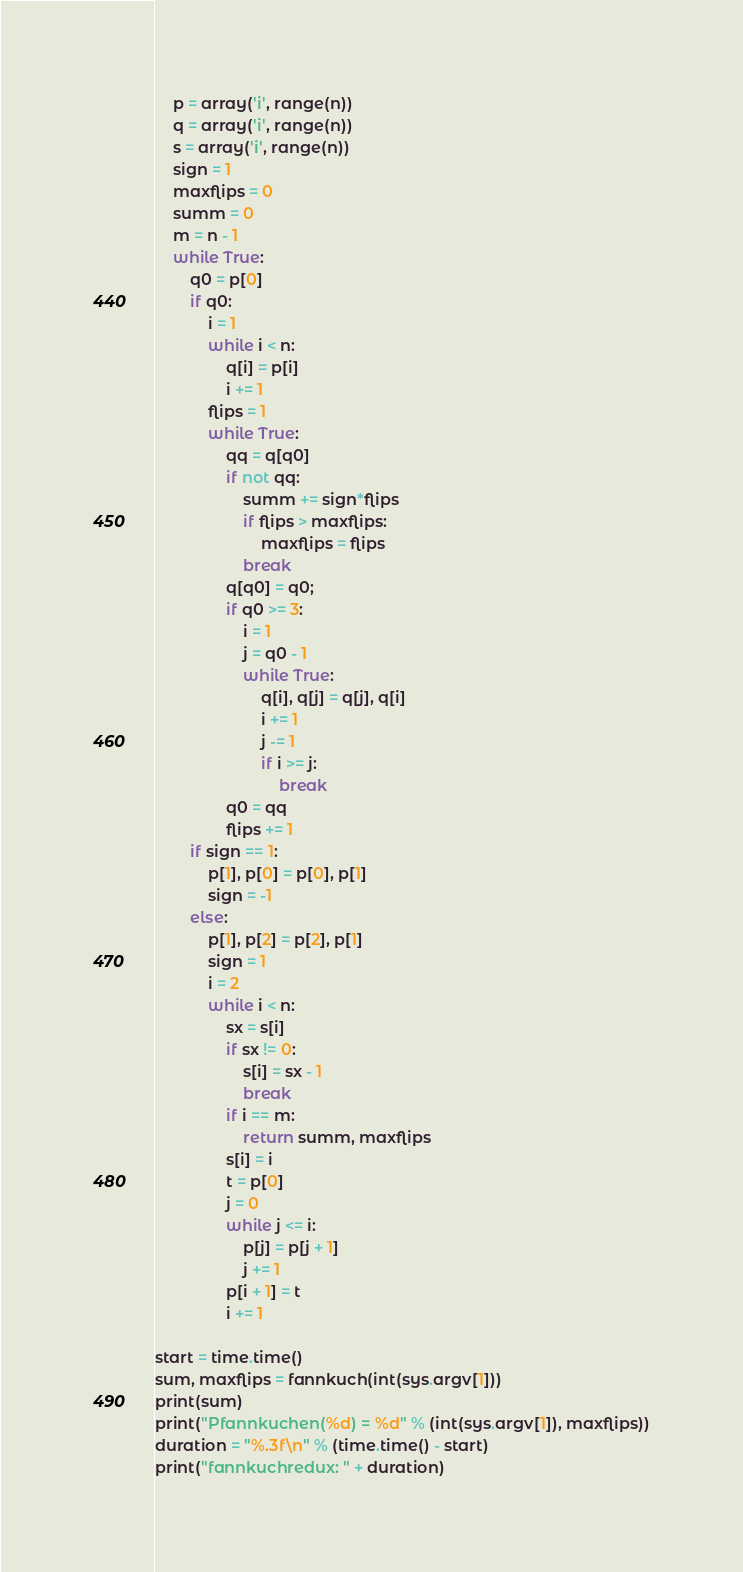<code> <loc_0><loc_0><loc_500><loc_500><_Python_>    p = array('i', range(n))
    q = array('i', range(n))
    s = array('i', range(n))
    sign = 1
    maxflips = 0
    summ = 0
    m = n - 1
    while True:
        q0 = p[0]
        if q0:
            i = 1
            while i < n:
                q[i] = p[i]
                i += 1
            flips = 1
            while True:
                qq = q[q0]
                if not qq:
                    summ += sign*flips
                    if flips > maxflips:
                        maxflips = flips
                    break
                q[q0] = q0;
                if q0 >= 3:
                    i = 1
                    j = q0 - 1
                    while True:
                        q[i], q[j] = q[j], q[i]
                        i += 1
                        j -= 1
                        if i >= j:
                            break
                q0 = qq
                flips += 1
        if sign == 1:
            p[1], p[0] = p[0], p[1]
            sign = -1
        else:
            p[1], p[2] = p[2], p[1]
            sign = 1
            i = 2
            while i < n:
                sx = s[i]
                if sx != 0:
                    s[i] = sx - 1
                    break
                if i == m:
                    return summ, maxflips
                s[i] = i
                t = p[0]
                j = 0
                while j <= i:
                    p[j] = p[j + 1]
                    j += 1
                p[i + 1] = t
                i += 1

start = time.time()
sum, maxflips = fannkuch(int(sys.argv[1]))
print(sum)
print("Pfannkuchen(%d) = %d" % (int(sys.argv[1]), maxflips))
duration = "%.3f\n" % (time.time() - start)
print("fannkuchredux: " + duration)
</code> 